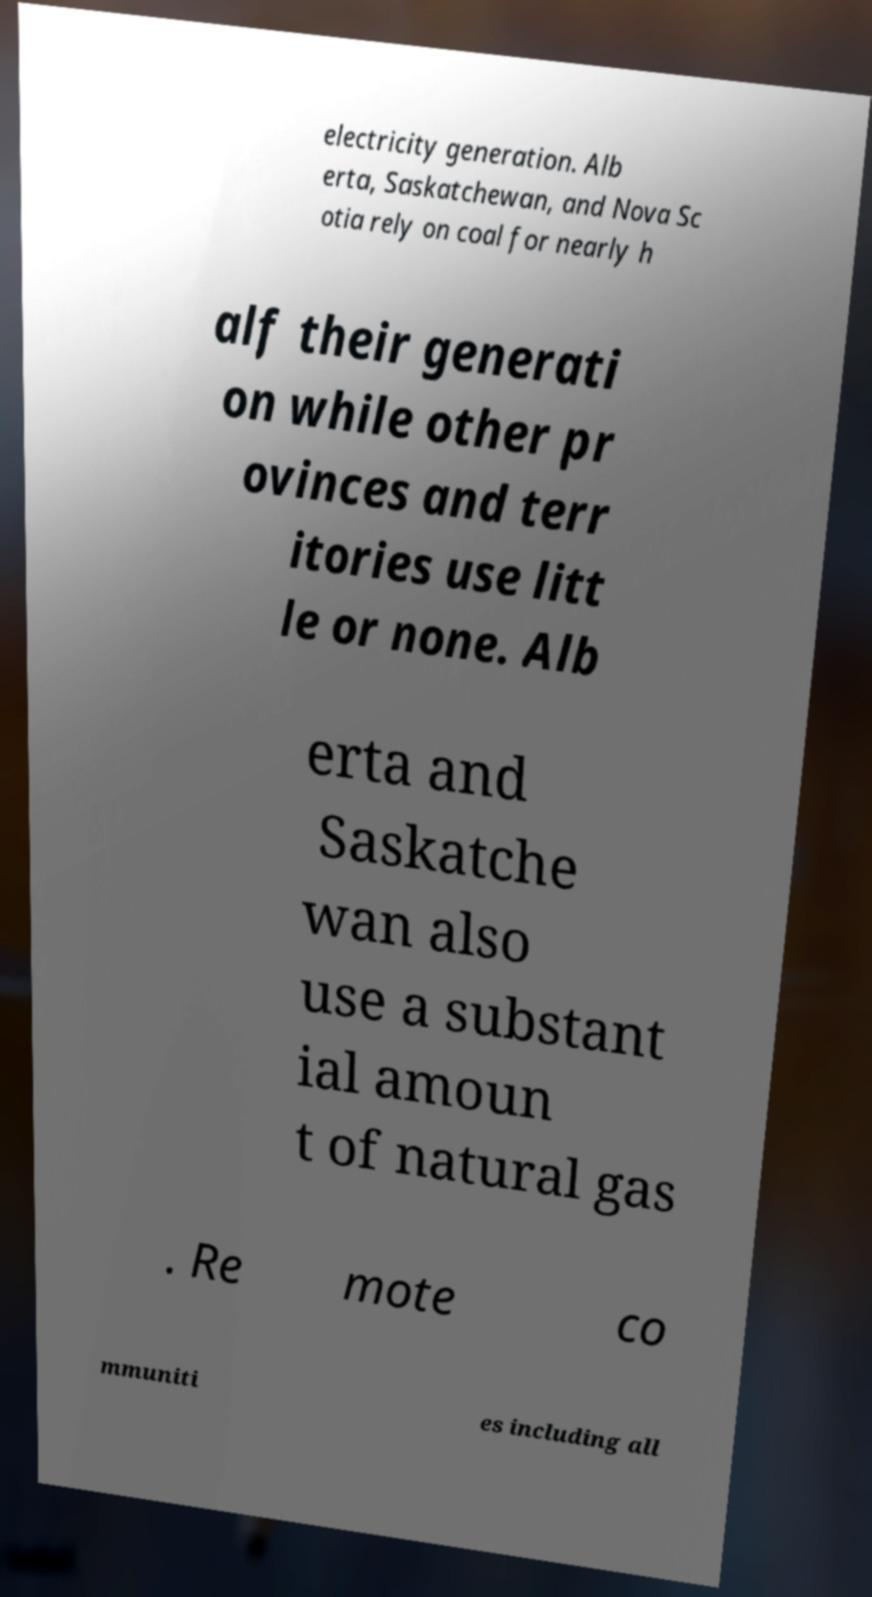Could you assist in decoding the text presented in this image and type it out clearly? electricity generation. Alb erta, Saskatchewan, and Nova Sc otia rely on coal for nearly h alf their generati on while other pr ovinces and terr itories use litt le or none. Alb erta and Saskatche wan also use a substant ial amoun t of natural gas . Re mote co mmuniti es including all 